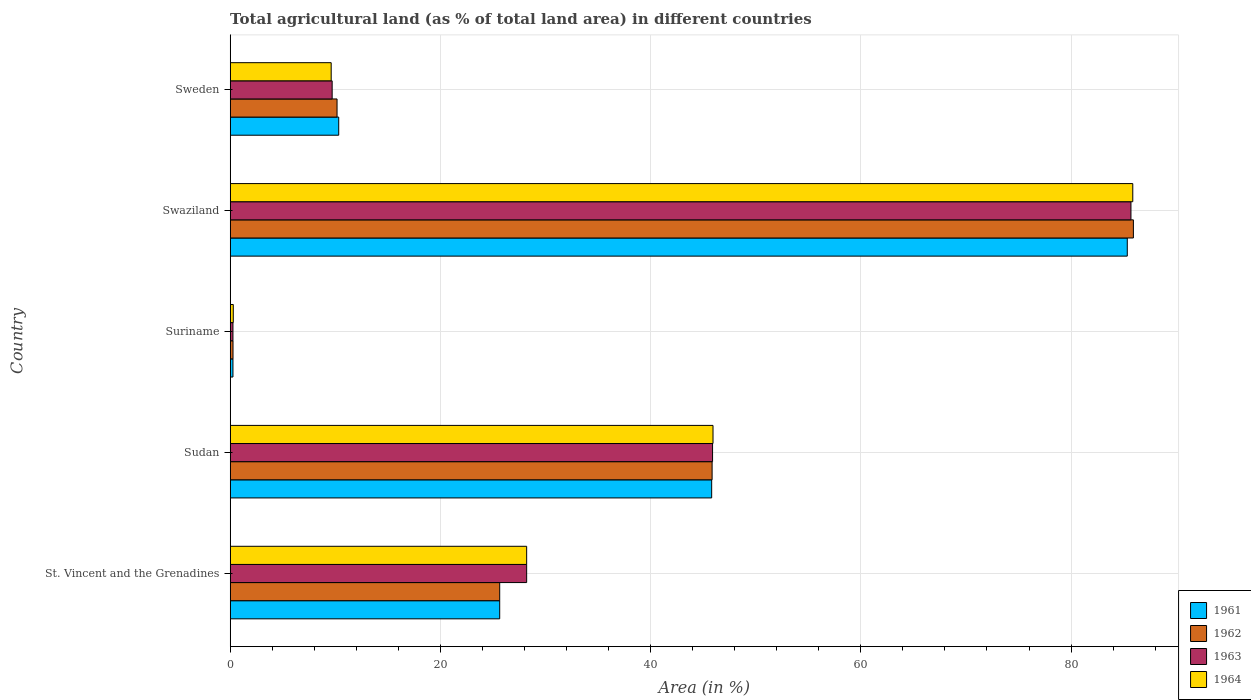How many groups of bars are there?
Make the answer very short. 5. Are the number of bars per tick equal to the number of legend labels?
Offer a terse response. Yes. Are the number of bars on each tick of the Y-axis equal?
Ensure brevity in your answer.  Yes. How many bars are there on the 5th tick from the bottom?
Offer a very short reply. 4. What is the label of the 2nd group of bars from the top?
Keep it short and to the point. Swaziland. In how many cases, is the number of bars for a given country not equal to the number of legend labels?
Your answer should be compact. 0. What is the percentage of agricultural land in 1964 in Suriname?
Give a very brief answer. 0.29. Across all countries, what is the maximum percentage of agricultural land in 1963?
Keep it short and to the point. 85.7. Across all countries, what is the minimum percentage of agricultural land in 1962?
Provide a succinct answer. 0.27. In which country was the percentage of agricultural land in 1964 maximum?
Your answer should be very brief. Swaziland. In which country was the percentage of agricultural land in 1961 minimum?
Provide a succinct answer. Suriname. What is the total percentage of agricultural land in 1962 in the graph?
Your response must be concise. 167.86. What is the difference between the percentage of agricultural land in 1962 in St. Vincent and the Grenadines and that in Sudan?
Provide a succinct answer. -20.21. What is the difference between the percentage of agricultural land in 1963 in St. Vincent and the Grenadines and the percentage of agricultural land in 1962 in Sweden?
Offer a terse response. 18.04. What is the average percentage of agricultural land in 1961 per country?
Ensure brevity in your answer.  33.48. What is the difference between the percentage of agricultural land in 1961 and percentage of agricultural land in 1964 in Sweden?
Your response must be concise. 0.72. What is the ratio of the percentage of agricultural land in 1964 in St. Vincent and the Grenadines to that in Sweden?
Provide a short and direct response. 2.94. What is the difference between the highest and the second highest percentage of agricultural land in 1964?
Your answer should be compact. 39.94. What is the difference between the highest and the lowest percentage of agricultural land in 1964?
Provide a short and direct response. 85.58. In how many countries, is the percentage of agricultural land in 1963 greater than the average percentage of agricultural land in 1963 taken over all countries?
Give a very brief answer. 2. Is the sum of the percentage of agricultural land in 1961 in Sudan and Suriname greater than the maximum percentage of agricultural land in 1963 across all countries?
Your answer should be compact. No. What does the 3rd bar from the top in Sweden represents?
Your answer should be very brief. 1962. What does the 1st bar from the bottom in Swaziland represents?
Ensure brevity in your answer.  1961. Is it the case that in every country, the sum of the percentage of agricultural land in 1963 and percentage of agricultural land in 1962 is greater than the percentage of agricultural land in 1961?
Your answer should be compact. Yes. Are all the bars in the graph horizontal?
Give a very brief answer. Yes. What is the difference between two consecutive major ticks on the X-axis?
Make the answer very short. 20. Does the graph contain grids?
Make the answer very short. Yes. Where does the legend appear in the graph?
Provide a short and direct response. Bottom right. How are the legend labels stacked?
Ensure brevity in your answer.  Vertical. What is the title of the graph?
Ensure brevity in your answer.  Total agricultural land (as % of total land area) in different countries. What is the label or title of the X-axis?
Offer a terse response. Area (in %). What is the Area (in %) of 1961 in St. Vincent and the Grenadines?
Ensure brevity in your answer.  25.64. What is the Area (in %) in 1962 in St. Vincent and the Grenadines?
Your answer should be very brief. 25.64. What is the Area (in %) in 1963 in St. Vincent and the Grenadines?
Give a very brief answer. 28.21. What is the Area (in %) of 1964 in St. Vincent and the Grenadines?
Provide a short and direct response. 28.21. What is the Area (in %) of 1961 in Sudan?
Your answer should be very brief. 45.81. What is the Area (in %) of 1962 in Sudan?
Ensure brevity in your answer.  45.85. What is the Area (in %) of 1963 in Sudan?
Your answer should be very brief. 45.89. What is the Area (in %) in 1964 in Sudan?
Make the answer very short. 45.94. What is the Area (in %) of 1961 in Suriname?
Your answer should be very brief. 0.26. What is the Area (in %) of 1962 in Suriname?
Make the answer very short. 0.27. What is the Area (in %) in 1963 in Suriname?
Your answer should be very brief. 0.26. What is the Area (in %) in 1964 in Suriname?
Your answer should be very brief. 0.29. What is the Area (in %) of 1961 in Swaziland?
Your answer should be very brief. 85.35. What is the Area (in %) in 1962 in Swaziland?
Your response must be concise. 85.93. What is the Area (in %) of 1963 in Swaziland?
Your answer should be very brief. 85.7. What is the Area (in %) of 1964 in Swaziland?
Make the answer very short. 85.87. What is the Area (in %) in 1961 in Sweden?
Provide a short and direct response. 10.33. What is the Area (in %) of 1962 in Sweden?
Keep it short and to the point. 10.17. What is the Area (in %) of 1963 in Sweden?
Make the answer very short. 9.7. What is the Area (in %) of 1964 in Sweden?
Provide a succinct answer. 9.61. Across all countries, what is the maximum Area (in %) in 1961?
Offer a terse response. 85.35. Across all countries, what is the maximum Area (in %) in 1962?
Give a very brief answer. 85.93. Across all countries, what is the maximum Area (in %) of 1963?
Your response must be concise. 85.7. Across all countries, what is the maximum Area (in %) of 1964?
Ensure brevity in your answer.  85.87. Across all countries, what is the minimum Area (in %) of 1961?
Give a very brief answer. 0.26. Across all countries, what is the minimum Area (in %) in 1962?
Ensure brevity in your answer.  0.27. Across all countries, what is the minimum Area (in %) of 1963?
Make the answer very short. 0.26. Across all countries, what is the minimum Area (in %) of 1964?
Your response must be concise. 0.29. What is the total Area (in %) in 1961 in the graph?
Make the answer very short. 167.39. What is the total Area (in %) of 1962 in the graph?
Make the answer very short. 167.86. What is the total Area (in %) in 1963 in the graph?
Offer a terse response. 169.76. What is the total Area (in %) in 1964 in the graph?
Keep it short and to the point. 169.92. What is the difference between the Area (in %) of 1961 in St. Vincent and the Grenadines and that in Sudan?
Your response must be concise. -20.17. What is the difference between the Area (in %) of 1962 in St. Vincent and the Grenadines and that in Sudan?
Keep it short and to the point. -20.21. What is the difference between the Area (in %) in 1963 in St. Vincent and the Grenadines and that in Sudan?
Provide a short and direct response. -17.69. What is the difference between the Area (in %) of 1964 in St. Vincent and the Grenadines and that in Sudan?
Offer a very short reply. -17.73. What is the difference between the Area (in %) of 1961 in St. Vincent and the Grenadines and that in Suriname?
Your answer should be very brief. 25.38. What is the difference between the Area (in %) in 1962 in St. Vincent and the Grenadines and that in Suriname?
Your answer should be compact. 25.37. What is the difference between the Area (in %) of 1963 in St. Vincent and the Grenadines and that in Suriname?
Your response must be concise. 27.94. What is the difference between the Area (in %) in 1964 in St. Vincent and the Grenadines and that in Suriname?
Make the answer very short. 27.91. What is the difference between the Area (in %) in 1961 in St. Vincent and the Grenadines and that in Swaziland?
Provide a succinct answer. -59.71. What is the difference between the Area (in %) of 1962 in St. Vincent and the Grenadines and that in Swaziland?
Offer a terse response. -60.29. What is the difference between the Area (in %) of 1963 in St. Vincent and the Grenadines and that in Swaziland?
Give a very brief answer. -57.49. What is the difference between the Area (in %) of 1964 in St. Vincent and the Grenadines and that in Swaziland?
Ensure brevity in your answer.  -57.67. What is the difference between the Area (in %) in 1961 in St. Vincent and the Grenadines and that in Sweden?
Give a very brief answer. 15.32. What is the difference between the Area (in %) of 1962 in St. Vincent and the Grenadines and that in Sweden?
Provide a succinct answer. 15.47. What is the difference between the Area (in %) in 1963 in St. Vincent and the Grenadines and that in Sweden?
Offer a very short reply. 18.5. What is the difference between the Area (in %) of 1964 in St. Vincent and the Grenadines and that in Sweden?
Offer a terse response. 18.6. What is the difference between the Area (in %) in 1961 in Sudan and that in Suriname?
Give a very brief answer. 45.55. What is the difference between the Area (in %) of 1962 in Sudan and that in Suriname?
Your response must be concise. 45.58. What is the difference between the Area (in %) of 1963 in Sudan and that in Suriname?
Offer a terse response. 45.63. What is the difference between the Area (in %) of 1964 in Sudan and that in Suriname?
Make the answer very short. 45.64. What is the difference between the Area (in %) in 1961 in Sudan and that in Swaziland?
Offer a terse response. -39.54. What is the difference between the Area (in %) of 1962 in Sudan and that in Swaziland?
Make the answer very short. -40.08. What is the difference between the Area (in %) of 1963 in Sudan and that in Swaziland?
Ensure brevity in your answer.  -39.81. What is the difference between the Area (in %) in 1964 in Sudan and that in Swaziland?
Provide a succinct answer. -39.94. What is the difference between the Area (in %) of 1961 in Sudan and that in Sweden?
Your response must be concise. 35.48. What is the difference between the Area (in %) of 1962 in Sudan and that in Sweden?
Make the answer very short. 35.68. What is the difference between the Area (in %) in 1963 in Sudan and that in Sweden?
Your answer should be compact. 36.19. What is the difference between the Area (in %) in 1964 in Sudan and that in Sweden?
Give a very brief answer. 36.33. What is the difference between the Area (in %) of 1961 in Suriname and that in Swaziland?
Your answer should be very brief. -85.09. What is the difference between the Area (in %) of 1962 in Suriname and that in Swaziland?
Give a very brief answer. -85.66. What is the difference between the Area (in %) of 1963 in Suriname and that in Swaziland?
Ensure brevity in your answer.  -85.43. What is the difference between the Area (in %) of 1964 in Suriname and that in Swaziland?
Your answer should be compact. -85.58. What is the difference between the Area (in %) in 1961 in Suriname and that in Sweden?
Offer a terse response. -10.06. What is the difference between the Area (in %) of 1962 in Suriname and that in Sweden?
Give a very brief answer. -9.9. What is the difference between the Area (in %) of 1963 in Suriname and that in Sweden?
Your answer should be very brief. -9.44. What is the difference between the Area (in %) of 1964 in Suriname and that in Sweden?
Your answer should be compact. -9.31. What is the difference between the Area (in %) in 1961 in Swaziland and that in Sweden?
Offer a terse response. 75.02. What is the difference between the Area (in %) in 1962 in Swaziland and that in Sweden?
Ensure brevity in your answer.  75.76. What is the difference between the Area (in %) in 1963 in Swaziland and that in Sweden?
Offer a very short reply. 76. What is the difference between the Area (in %) in 1964 in Swaziland and that in Sweden?
Provide a succinct answer. 76.26. What is the difference between the Area (in %) of 1961 in St. Vincent and the Grenadines and the Area (in %) of 1962 in Sudan?
Offer a terse response. -20.21. What is the difference between the Area (in %) in 1961 in St. Vincent and the Grenadines and the Area (in %) in 1963 in Sudan?
Your answer should be very brief. -20.25. What is the difference between the Area (in %) in 1961 in St. Vincent and the Grenadines and the Area (in %) in 1964 in Sudan?
Provide a short and direct response. -20.29. What is the difference between the Area (in %) of 1962 in St. Vincent and the Grenadines and the Area (in %) of 1963 in Sudan?
Your answer should be compact. -20.25. What is the difference between the Area (in %) in 1962 in St. Vincent and the Grenadines and the Area (in %) in 1964 in Sudan?
Your answer should be very brief. -20.29. What is the difference between the Area (in %) of 1963 in St. Vincent and the Grenadines and the Area (in %) of 1964 in Sudan?
Keep it short and to the point. -17.73. What is the difference between the Area (in %) of 1961 in St. Vincent and the Grenadines and the Area (in %) of 1962 in Suriname?
Offer a terse response. 25.37. What is the difference between the Area (in %) in 1961 in St. Vincent and the Grenadines and the Area (in %) in 1963 in Suriname?
Keep it short and to the point. 25.38. What is the difference between the Area (in %) of 1961 in St. Vincent and the Grenadines and the Area (in %) of 1964 in Suriname?
Make the answer very short. 25.35. What is the difference between the Area (in %) in 1962 in St. Vincent and the Grenadines and the Area (in %) in 1963 in Suriname?
Provide a succinct answer. 25.38. What is the difference between the Area (in %) in 1962 in St. Vincent and the Grenadines and the Area (in %) in 1964 in Suriname?
Your answer should be compact. 25.35. What is the difference between the Area (in %) of 1963 in St. Vincent and the Grenadines and the Area (in %) of 1964 in Suriname?
Provide a succinct answer. 27.91. What is the difference between the Area (in %) in 1961 in St. Vincent and the Grenadines and the Area (in %) in 1962 in Swaziland?
Offer a very short reply. -60.29. What is the difference between the Area (in %) in 1961 in St. Vincent and the Grenadines and the Area (in %) in 1963 in Swaziland?
Your response must be concise. -60.06. What is the difference between the Area (in %) in 1961 in St. Vincent and the Grenadines and the Area (in %) in 1964 in Swaziland?
Your answer should be very brief. -60.23. What is the difference between the Area (in %) of 1962 in St. Vincent and the Grenadines and the Area (in %) of 1963 in Swaziland?
Make the answer very short. -60.06. What is the difference between the Area (in %) in 1962 in St. Vincent and the Grenadines and the Area (in %) in 1964 in Swaziland?
Your response must be concise. -60.23. What is the difference between the Area (in %) of 1963 in St. Vincent and the Grenadines and the Area (in %) of 1964 in Swaziland?
Offer a very short reply. -57.67. What is the difference between the Area (in %) in 1961 in St. Vincent and the Grenadines and the Area (in %) in 1962 in Sweden?
Offer a very short reply. 15.47. What is the difference between the Area (in %) of 1961 in St. Vincent and the Grenadines and the Area (in %) of 1963 in Sweden?
Make the answer very short. 15.94. What is the difference between the Area (in %) in 1961 in St. Vincent and the Grenadines and the Area (in %) in 1964 in Sweden?
Offer a very short reply. 16.03. What is the difference between the Area (in %) of 1962 in St. Vincent and the Grenadines and the Area (in %) of 1963 in Sweden?
Give a very brief answer. 15.94. What is the difference between the Area (in %) in 1962 in St. Vincent and the Grenadines and the Area (in %) in 1964 in Sweden?
Provide a short and direct response. 16.03. What is the difference between the Area (in %) of 1963 in St. Vincent and the Grenadines and the Area (in %) of 1964 in Sweden?
Keep it short and to the point. 18.6. What is the difference between the Area (in %) in 1961 in Sudan and the Area (in %) in 1962 in Suriname?
Give a very brief answer. 45.54. What is the difference between the Area (in %) of 1961 in Sudan and the Area (in %) of 1963 in Suriname?
Offer a terse response. 45.55. What is the difference between the Area (in %) in 1961 in Sudan and the Area (in %) in 1964 in Suriname?
Provide a succinct answer. 45.51. What is the difference between the Area (in %) in 1962 in Sudan and the Area (in %) in 1963 in Suriname?
Your answer should be compact. 45.59. What is the difference between the Area (in %) in 1962 in Sudan and the Area (in %) in 1964 in Suriname?
Your answer should be very brief. 45.56. What is the difference between the Area (in %) of 1963 in Sudan and the Area (in %) of 1964 in Suriname?
Your response must be concise. 45.6. What is the difference between the Area (in %) of 1961 in Sudan and the Area (in %) of 1962 in Swaziland?
Ensure brevity in your answer.  -40.12. What is the difference between the Area (in %) of 1961 in Sudan and the Area (in %) of 1963 in Swaziland?
Your response must be concise. -39.89. What is the difference between the Area (in %) in 1961 in Sudan and the Area (in %) in 1964 in Swaziland?
Your answer should be very brief. -40.06. What is the difference between the Area (in %) in 1962 in Sudan and the Area (in %) in 1963 in Swaziland?
Offer a terse response. -39.85. What is the difference between the Area (in %) of 1962 in Sudan and the Area (in %) of 1964 in Swaziland?
Your answer should be very brief. -40.02. What is the difference between the Area (in %) of 1963 in Sudan and the Area (in %) of 1964 in Swaziland?
Give a very brief answer. -39.98. What is the difference between the Area (in %) of 1961 in Sudan and the Area (in %) of 1962 in Sweden?
Your answer should be very brief. 35.64. What is the difference between the Area (in %) in 1961 in Sudan and the Area (in %) in 1963 in Sweden?
Your response must be concise. 36.11. What is the difference between the Area (in %) in 1961 in Sudan and the Area (in %) in 1964 in Sweden?
Provide a succinct answer. 36.2. What is the difference between the Area (in %) in 1962 in Sudan and the Area (in %) in 1963 in Sweden?
Offer a terse response. 36.15. What is the difference between the Area (in %) of 1962 in Sudan and the Area (in %) of 1964 in Sweden?
Make the answer very short. 36.24. What is the difference between the Area (in %) in 1963 in Sudan and the Area (in %) in 1964 in Sweden?
Your answer should be very brief. 36.28. What is the difference between the Area (in %) of 1961 in Suriname and the Area (in %) of 1962 in Swaziland?
Provide a short and direct response. -85.67. What is the difference between the Area (in %) of 1961 in Suriname and the Area (in %) of 1963 in Swaziland?
Provide a short and direct response. -85.43. What is the difference between the Area (in %) of 1961 in Suriname and the Area (in %) of 1964 in Swaziland?
Your answer should be very brief. -85.61. What is the difference between the Area (in %) in 1962 in Suriname and the Area (in %) in 1963 in Swaziland?
Provide a short and direct response. -85.43. What is the difference between the Area (in %) in 1962 in Suriname and the Area (in %) in 1964 in Swaziland?
Make the answer very short. -85.6. What is the difference between the Area (in %) of 1963 in Suriname and the Area (in %) of 1964 in Swaziland?
Keep it short and to the point. -85.61. What is the difference between the Area (in %) in 1961 in Suriname and the Area (in %) in 1962 in Sweden?
Provide a short and direct response. -9.9. What is the difference between the Area (in %) of 1961 in Suriname and the Area (in %) of 1963 in Sweden?
Provide a short and direct response. -9.44. What is the difference between the Area (in %) in 1961 in Suriname and the Area (in %) in 1964 in Sweden?
Give a very brief answer. -9.35. What is the difference between the Area (in %) in 1962 in Suriname and the Area (in %) in 1963 in Sweden?
Offer a terse response. -9.43. What is the difference between the Area (in %) of 1962 in Suriname and the Area (in %) of 1964 in Sweden?
Your response must be concise. -9.34. What is the difference between the Area (in %) of 1963 in Suriname and the Area (in %) of 1964 in Sweden?
Provide a succinct answer. -9.35. What is the difference between the Area (in %) of 1961 in Swaziland and the Area (in %) of 1962 in Sweden?
Provide a short and direct response. 75.18. What is the difference between the Area (in %) in 1961 in Swaziland and the Area (in %) in 1963 in Sweden?
Keep it short and to the point. 75.65. What is the difference between the Area (in %) of 1961 in Swaziland and the Area (in %) of 1964 in Sweden?
Your answer should be very brief. 75.74. What is the difference between the Area (in %) of 1962 in Swaziland and the Area (in %) of 1963 in Sweden?
Your answer should be compact. 76.23. What is the difference between the Area (in %) in 1962 in Swaziland and the Area (in %) in 1964 in Sweden?
Your answer should be very brief. 76.32. What is the difference between the Area (in %) in 1963 in Swaziland and the Area (in %) in 1964 in Sweden?
Offer a terse response. 76.09. What is the average Area (in %) of 1961 per country?
Give a very brief answer. 33.48. What is the average Area (in %) in 1962 per country?
Keep it short and to the point. 33.57. What is the average Area (in %) in 1963 per country?
Offer a very short reply. 33.95. What is the average Area (in %) in 1964 per country?
Your response must be concise. 33.98. What is the difference between the Area (in %) in 1961 and Area (in %) in 1962 in St. Vincent and the Grenadines?
Provide a succinct answer. 0. What is the difference between the Area (in %) of 1961 and Area (in %) of 1963 in St. Vincent and the Grenadines?
Give a very brief answer. -2.56. What is the difference between the Area (in %) of 1961 and Area (in %) of 1964 in St. Vincent and the Grenadines?
Keep it short and to the point. -2.56. What is the difference between the Area (in %) in 1962 and Area (in %) in 1963 in St. Vincent and the Grenadines?
Ensure brevity in your answer.  -2.56. What is the difference between the Area (in %) of 1962 and Area (in %) of 1964 in St. Vincent and the Grenadines?
Your response must be concise. -2.56. What is the difference between the Area (in %) in 1963 and Area (in %) in 1964 in St. Vincent and the Grenadines?
Your answer should be very brief. 0. What is the difference between the Area (in %) in 1961 and Area (in %) in 1962 in Sudan?
Provide a succinct answer. -0.04. What is the difference between the Area (in %) of 1961 and Area (in %) of 1963 in Sudan?
Provide a short and direct response. -0.08. What is the difference between the Area (in %) of 1961 and Area (in %) of 1964 in Sudan?
Provide a succinct answer. -0.13. What is the difference between the Area (in %) of 1962 and Area (in %) of 1963 in Sudan?
Provide a short and direct response. -0.04. What is the difference between the Area (in %) in 1962 and Area (in %) in 1964 in Sudan?
Keep it short and to the point. -0.09. What is the difference between the Area (in %) of 1963 and Area (in %) of 1964 in Sudan?
Keep it short and to the point. -0.04. What is the difference between the Area (in %) in 1961 and Area (in %) in 1962 in Suriname?
Provide a succinct answer. -0.01. What is the difference between the Area (in %) of 1961 and Area (in %) of 1963 in Suriname?
Your answer should be very brief. 0. What is the difference between the Area (in %) of 1961 and Area (in %) of 1964 in Suriname?
Give a very brief answer. -0.03. What is the difference between the Area (in %) in 1962 and Area (in %) in 1963 in Suriname?
Ensure brevity in your answer.  0.01. What is the difference between the Area (in %) in 1962 and Area (in %) in 1964 in Suriname?
Give a very brief answer. -0.03. What is the difference between the Area (in %) of 1963 and Area (in %) of 1964 in Suriname?
Your response must be concise. -0.03. What is the difference between the Area (in %) in 1961 and Area (in %) in 1962 in Swaziland?
Offer a terse response. -0.58. What is the difference between the Area (in %) in 1961 and Area (in %) in 1963 in Swaziland?
Ensure brevity in your answer.  -0.35. What is the difference between the Area (in %) of 1961 and Area (in %) of 1964 in Swaziland?
Your answer should be very brief. -0.52. What is the difference between the Area (in %) in 1962 and Area (in %) in 1963 in Swaziland?
Your answer should be very brief. 0.23. What is the difference between the Area (in %) in 1962 and Area (in %) in 1964 in Swaziland?
Provide a short and direct response. 0.06. What is the difference between the Area (in %) of 1963 and Area (in %) of 1964 in Swaziland?
Ensure brevity in your answer.  -0.17. What is the difference between the Area (in %) of 1961 and Area (in %) of 1962 in Sweden?
Your answer should be very brief. 0.16. What is the difference between the Area (in %) of 1961 and Area (in %) of 1963 in Sweden?
Your response must be concise. 0.62. What is the difference between the Area (in %) in 1961 and Area (in %) in 1964 in Sweden?
Your response must be concise. 0.72. What is the difference between the Area (in %) in 1962 and Area (in %) in 1963 in Sweden?
Offer a very short reply. 0.47. What is the difference between the Area (in %) in 1962 and Area (in %) in 1964 in Sweden?
Make the answer very short. 0.56. What is the difference between the Area (in %) of 1963 and Area (in %) of 1964 in Sweden?
Your answer should be very brief. 0.09. What is the ratio of the Area (in %) in 1961 in St. Vincent and the Grenadines to that in Sudan?
Offer a terse response. 0.56. What is the ratio of the Area (in %) in 1962 in St. Vincent and the Grenadines to that in Sudan?
Your response must be concise. 0.56. What is the ratio of the Area (in %) of 1963 in St. Vincent and the Grenadines to that in Sudan?
Offer a very short reply. 0.61. What is the ratio of the Area (in %) in 1964 in St. Vincent and the Grenadines to that in Sudan?
Make the answer very short. 0.61. What is the ratio of the Area (in %) of 1961 in St. Vincent and the Grenadines to that in Suriname?
Provide a short and direct response. 97.56. What is the ratio of the Area (in %) of 1962 in St. Vincent and the Grenadines to that in Suriname?
Keep it short and to the point. 95.24. What is the ratio of the Area (in %) of 1963 in St. Vincent and the Grenadines to that in Suriname?
Your answer should be compact. 107.32. What is the ratio of the Area (in %) of 1964 in St. Vincent and the Grenadines to that in Suriname?
Provide a succinct answer. 95.65. What is the ratio of the Area (in %) of 1961 in St. Vincent and the Grenadines to that in Swaziland?
Offer a terse response. 0.3. What is the ratio of the Area (in %) of 1962 in St. Vincent and the Grenadines to that in Swaziland?
Keep it short and to the point. 0.3. What is the ratio of the Area (in %) in 1963 in St. Vincent and the Grenadines to that in Swaziland?
Keep it short and to the point. 0.33. What is the ratio of the Area (in %) in 1964 in St. Vincent and the Grenadines to that in Swaziland?
Offer a very short reply. 0.33. What is the ratio of the Area (in %) of 1961 in St. Vincent and the Grenadines to that in Sweden?
Provide a short and direct response. 2.48. What is the ratio of the Area (in %) in 1962 in St. Vincent and the Grenadines to that in Sweden?
Offer a very short reply. 2.52. What is the ratio of the Area (in %) in 1963 in St. Vincent and the Grenadines to that in Sweden?
Provide a succinct answer. 2.91. What is the ratio of the Area (in %) of 1964 in St. Vincent and the Grenadines to that in Sweden?
Give a very brief answer. 2.94. What is the ratio of the Area (in %) of 1961 in Sudan to that in Suriname?
Your answer should be very brief. 174.29. What is the ratio of the Area (in %) of 1962 in Sudan to that in Suriname?
Offer a terse response. 170.3. What is the ratio of the Area (in %) in 1963 in Sudan to that in Suriname?
Make the answer very short. 174.61. What is the ratio of the Area (in %) in 1964 in Sudan to that in Suriname?
Make the answer very short. 155.78. What is the ratio of the Area (in %) of 1961 in Sudan to that in Swaziland?
Provide a short and direct response. 0.54. What is the ratio of the Area (in %) of 1962 in Sudan to that in Swaziland?
Your answer should be very brief. 0.53. What is the ratio of the Area (in %) in 1963 in Sudan to that in Swaziland?
Your answer should be very brief. 0.54. What is the ratio of the Area (in %) in 1964 in Sudan to that in Swaziland?
Provide a short and direct response. 0.53. What is the ratio of the Area (in %) in 1961 in Sudan to that in Sweden?
Your response must be concise. 4.44. What is the ratio of the Area (in %) of 1962 in Sudan to that in Sweden?
Your answer should be compact. 4.51. What is the ratio of the Area (in %) in 1963 in Sudan to that in Sweden?
Offer a very short reply. 4.73. What is the ratio of the Area (in %) of 1964 in Sudan to that in Sweden?
Offer a very short reply. 4.78. What is the ratio of the Area (in %) of 1961 in Suriname to that in Swaziland?
Provide a succinct answer. 0. What is the ratio of the Area (in %) in 1962 in Suriname to that in Swaziland?
Provide a succinct answer. 0. What is the ratio of the Area (in %) of 1963 in Suriname to that in Swaziland?
Your response must be concise. 0. What is the ratio of the Area (in %) of 1964 in Suriname to that in Swaziland?
Provide a succinct answer. 0. What is the ratio of the Area (in %) in 1961 in Suriname to that in Sweden?
Make the answer very short. 0.03. What is the ratio of the Area (in %) in 1962 in Suriname to that in Sweden?
Offer a very short reply. 0.03. What is the ratio of the Area (in %) in 1963 in Suriname to that in Sweden?
Your response must be concise. 0.03. What is the ratio of the Area (in %) in 1964 in Suriname to that in Sweden?
Your answer should be compact. 0.03. What is the ratio of the Area (in %) in 1961 in Swaziland to that in Sweden?
Give a very brief answer. 8.27. What is the ratio of the Area (in %) in 1962 in Swaziland to that in Sweden?
Your answer should be very brief. 8.45. What is the ratio of the Area (in %) of 1963 in Swaziland to that in Sweden?
Keep it short and to the point. 8.83. What is the ratio of the Area (in %) in 1964 in Swaziland to that in Sweden?
Your answer should be compact. 8.94. What is the difference between the highest and the second highest Area (in %) in 1961?
Keep it short and to the point. 39.54. What is the difference between the highest and the second highest Area (in %) of 1962?
Offer a very short reply. 40.08. What is the difference between the highest and the second highest Area (in %) in 1963?
Your response must be concise. 39.81. What is the difference between the highest and the second highest Area (in %) in 1964?
Give a very brief answer. 39.94. What is the difference between the highest and the lowest Area (in %) of 1961?
Provide a short and direct response. 85.09. What is the difference between the highest and the lowest Area (in %) in 1962?
Give a very brief answer. 85.66. What is the difference between the highest and the lowest Area (in %) of 1963?
Your answer should be very brief. 85.43. What is the difference between the highest and the lowest Area (in %) of 1964?
Provide a short and direct response. 85.58. 